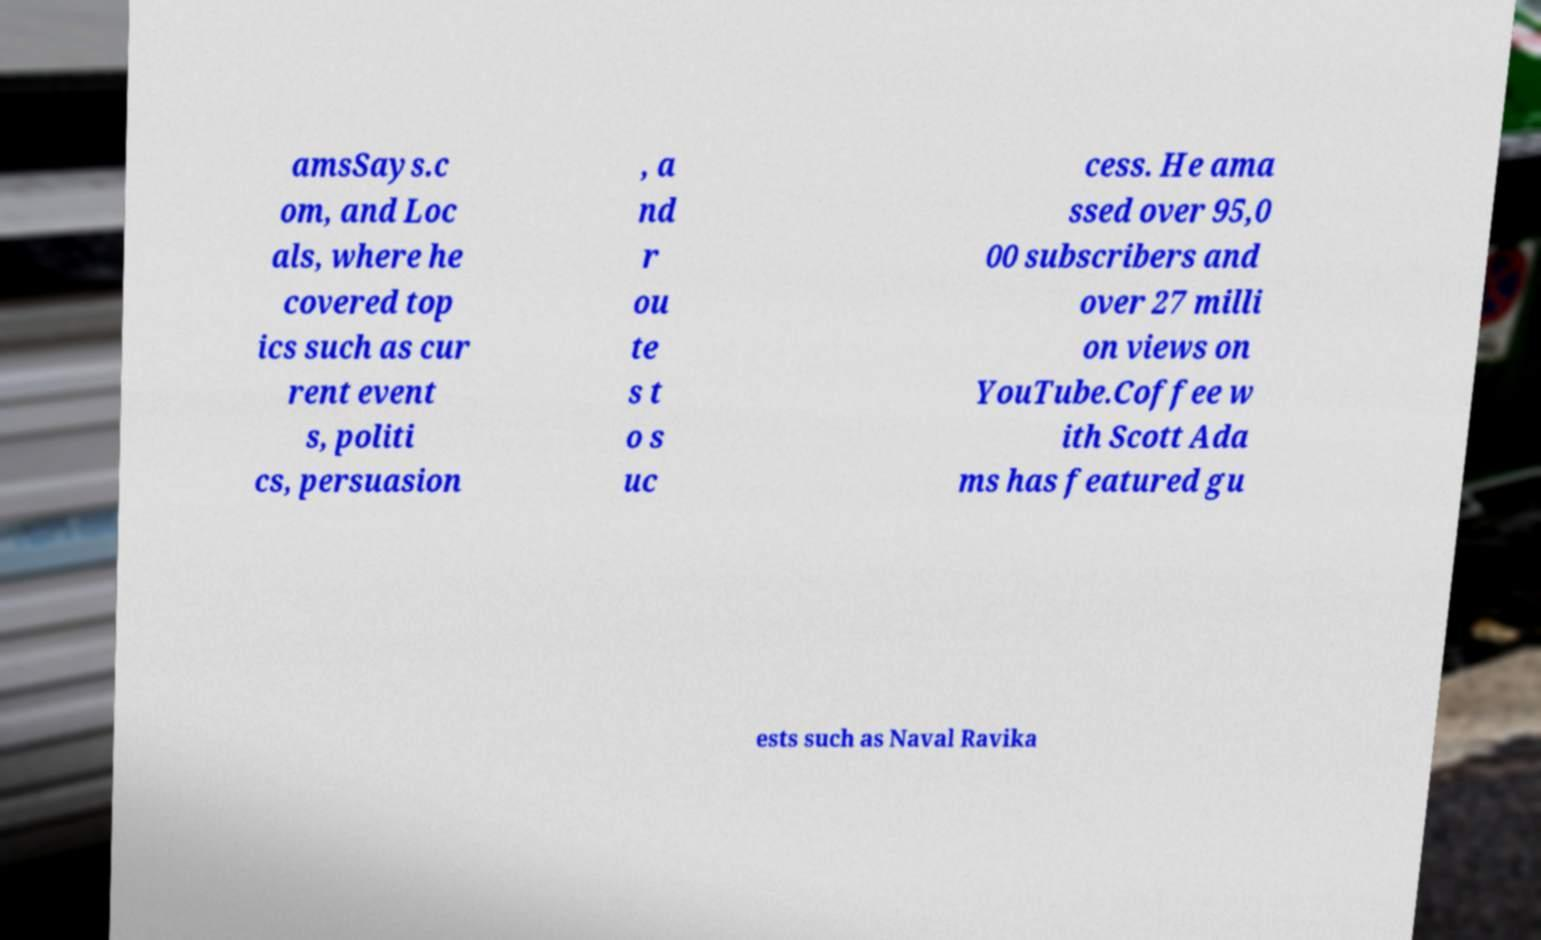I need the written content from this picture converted into text. Can you do that? amsSays.c om, and Loc als, where he covered top ics such as cur rent event s, politi cs, persuasion , a nd r ou te s t o s uc cess. He ama ssed over 95,0 00 subscribers and over 27 milli on views on YouTube.Coffee w ith Scott Ada ms has featured gu ests such as Naval Ravika 